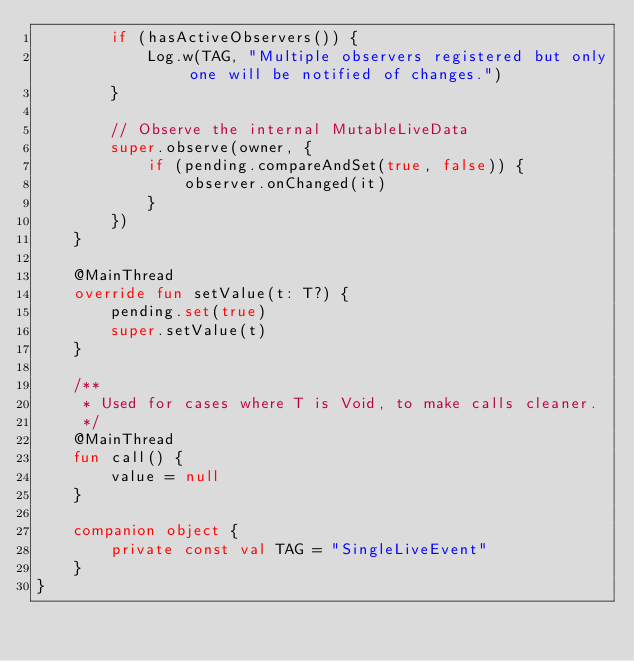Convert code to text. <code><loc_0><loc_0><loc_500><loc_500><_Kotlin_>        if (hasActiveObservers()) {
            Log.w(TAG, "Multiple observers registered but only one will be notified of changes.")
        }

        // Observe the internal MutableLiveData
        super.observe(owner, {
            if (pending.compareAndSet(true, false)) {
                observer.onChanged(it)
            }
        })
    }

    @MainThread
    override fun setValue(t: T?) {
        pending.set(true)
        super.setValue(t)
    }

    /**
     * Used for cases where T is Void, to make calls cleaner.
     */
    @MainThread
    fun call() {
        value = null
    }

    companion object {
        private const val TAG = "SingleLiveEvent"
    }
}</code> 